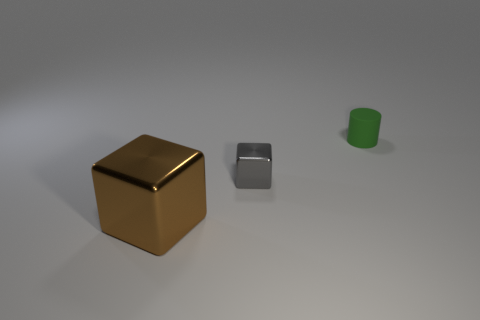Add 3 shiny blocks. How many objects exist? 6 Subtract all cylinders. How many objects are left? 2 Add 1 tiny rubber cylinders. How many tiny rubber cylinders are left? 2 Add 1 small gray metallic cubes. How many small gray metallic cubes exist? 2 Subtract 0 purple cylinders. How many objects are left? 3 Subtract all red cubes. Subtract all brown cylinders. How many cubes are left? 2 Subtract all large brown blocks. Subtract all small red shiny cubes. How many objects are left? 2 